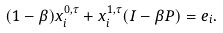<formula> <loc_0><loc_0><loc_500><loc_500>( 1 - \beta ) x _ { i } ^ { 0 , \tau } + x _ { i } ^ { 1 , \tau } ( I - \beta P ) = e _ { i } .</formula> 